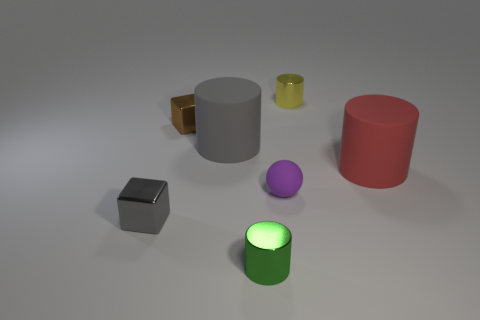Do the green thing and the metal block that is behind the large red rubber cylinder have the same size?
Your answer should be very brief. Yes. Does the metal cylinder that is in front of the red cylinder have the same size as the large gray matte object?
Your response must be concise. No. What number of other objects are there of the same material as the gray cylinder?
Your answer should be very brief. 2. Are there the same number of purple rubber things behind the gray cylinder and large red rubber objects that are in front of the tiny purple rubber ball?
Offer a terse response. Yes. What is the color of the small cube behind the metal object to the left of the cube that is behind the gray metal block?
Offer a terse response. Brown. What is the shape of the big matte object left of the large red matte thing?
Offer a very short reply. Cylinder. What shape is the gray thing that is the same material as the small green object?
Your answer should be compact. Cube. Is there anything else that has the same shape as the small rubber thing?
Provide a short and direct response. No. How many small purple matte balls are on the left side of the small purple matte object?
Give a very brief answer. 0. Is the number of tiny brown shiny objects left of the tiny brown thing the same as the number of cyan cylinders?
Ensure brevity in your answer.  Yes. 